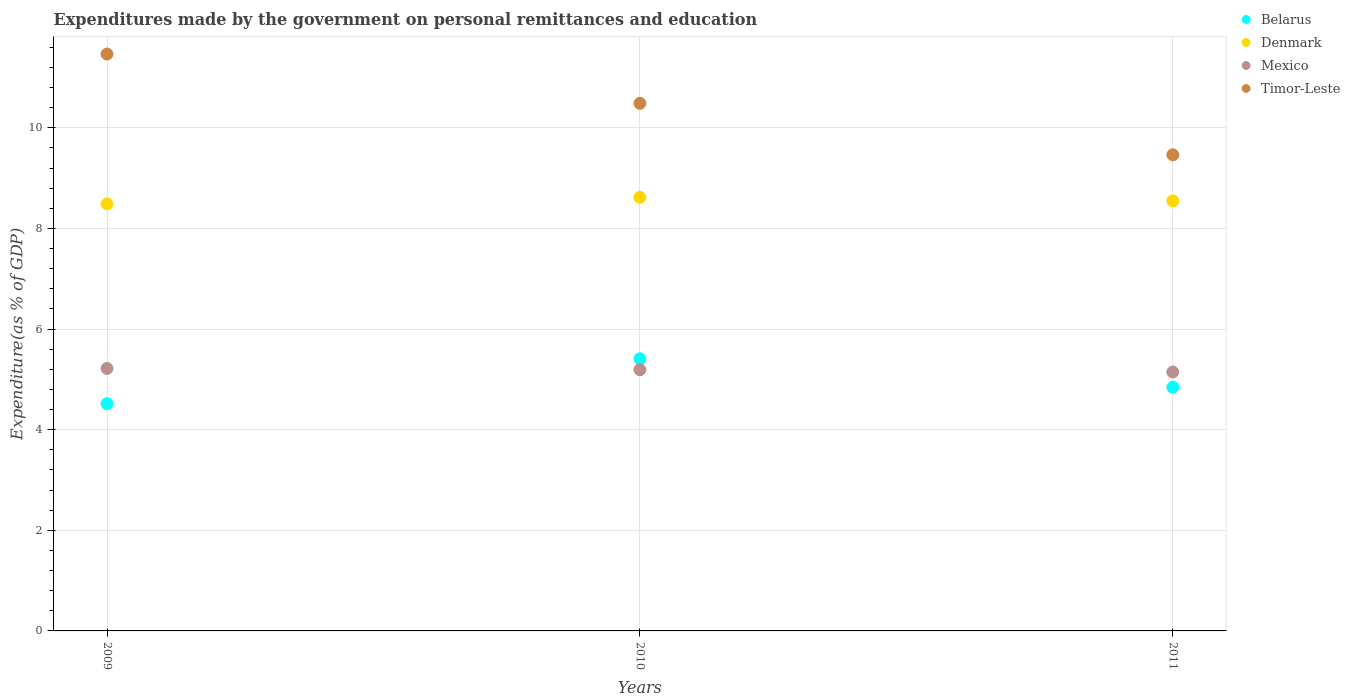What is the expenditures made by the government on personal remittances and education in Timor-Leste in 2010?
Your answer should be very brief. 10.49. Across all years, what is the maximum expenditures made by the government on personal remittances and education in Denmark?
Your answer should be very brief. 8.62. Across all years, what is the minimum expenditures made by the government on personal remittances and education in Timor-Leste?
Ensure brevity in your answer.  9.46. In which year was the expenditures made by the government on personal remittances and education in Timor-Leste minimum?
Give a very brief answer. 2011. What is the total expenditures made by the government on personal remittances and education in Mexico in the graph?
Your response must be concise. 15.56. What is the difference between the expenditures made by the government on personal remittances and education in Belarus in 2009 and that in 2010?
Give a very brief answer. -0.89. What is the difference between the expenditures made by the government on personal remittances and education in Denmark in 2011 and the expenditures made by the government on personal remittances and education in Belarus in 2009?
Your answer should be very brief. 4.03. What is the average expenditures made by the government on personal remittances and education in Belarus per year?
Provide a succinct answer. 4.92. In the year 2010, what is the difference between the expenditures made by the government on personal remittances and education in Mexico and expenditures made by the government on personal remittances and education in Belarus?
Offer a very short reply. -0.22. In how many years, is the expenditures made by the government on personal remittances and education in Denmark greater than 4 %?
Provide a succinct answer. 3. What is the ratio of the expenditures made by the government on personal remittances and education in Mexico in 2010 to that in 2011?
Make the answer very short. 1.01. Is the expenditures made by the government on personal remittances and education in Belarus in 2009 less than that in 2011?
Ensure brevity in your answer.  Yes. What is the difference between the highest and the second highest expenditures made by the government on personal remittances and education in Denmark?
Ensure brevity in your answer.  0.07. What is the difference between the highest and the lowest expenditures made by the government on personal remittances and education in Denmark?
Your answer should be very brief. 0.13. In how many years, is the expenditures made by the government on personal remittances and education in Timor-Leste greater than the average expenditures made by the government on personal remittances and education in Timor-Leste taken over all years?
Your response must be concise. 2. Is it the case that in every year, the sum of the expenditures made by the government on personal remittances and education in Timor-Leste and expenditures made by the government on personal remittances and education in Belarus  is greater than the sum of expenditures made by the government on personal remittances and education in Mexico and expenditures made by the government on personal remittances and education in Denmark?
Make the answer very short. Yes. How many dotlines are there?
Your answer should be very brief. 4. Where does the legend appear in the graph?
Ensure brevity in your answer.  Top right. What is the title of the graph?
Offer a terse response. Expenditures made by the government on personal remittances and education. Does "American Samoa" appear as one of the legend labels in the graph?
Make the answer very short. No. What is the label or title of the Y-axis?
Provide a short and direct response. Expenditure(as % of GDP). What is the Expenditure(as % of GDP) of Belarus in 2009?
Make the answer very short. 4.52. What is the Expenditure(as % of GDP) of Denmark in 2009?
Provide a succinct answer. 8.49. What is the Expenditure(as % of GDP) in Mexico in 2009?
Make the answer very short. 5.22. What is the Expenditure(as % of GDP) of Timor-Leste in 2009?
Your answer should be compact. 11.47. What is the Expenditure(as % of GDP) in Belarus in 2010?
Make the answer very short. 5.41. What is the Expenditure(as % of GDP) of Denmark in 2010?
Your response must be concise. 8.62. What is the Expenditure(as % of GDP) of Mexico in 2010?
Ensure brevity in your answer.  5.19. What is the Expenditure(as % of GDP) of Timor-Leste in 2010?
Offer a very short reply. 10.49. What is the Expenditure(as % of GDP) in Belarus in 2011?
Ensure brevity in your answer.  4.84. What is the Expenditure(as % of GDP) of Denmark in 2011?
Make the answer very short. 8.55. What is the Expenditure(as % of GDP) in Mexico in 2011?
Your answer should be compact. 5.15. What is the Expenditure(as % of GDP) of Timor-Leste in 2011?
Your response must be concise. 9.46. Across all years, what is the maximum Expenditure(as % of GDP) of Belarus?
Your answer should be compact. 5.41. Across all years, what is the maximum Expenditure(as % of GDP) of Denmark?
Your response must be concise. 8.62. Across all years, what is the maximum Expenditure(as % of GDP) of Mexico?
Your answer should be very brief. 5.22. Across all years, what is the maximum Expenditure(as % of GDP) of Timor-Leste?
Ensure brevity in your answer.  11.47. Across all years, what is the minimum Expenditure(as % of GDP) in Belarus?
Ensure brevity in your answer.  4.52. Across all years, what is the minimum Expenditure(as % of GDP) in Denmark?
Provide a short and direct response. 8.49. Across all years, what is the minimum Expenditure(as % of GDP) in Mexico?
Offer a very short reply. 5.15. Across all years, what is the minimum Expenditure(as % of GDP) of Timor-Leste?
Offer a very short reply. 9.46. What is the total Expenditure(as % of GDP) of Belarus in the graph?
Offer a terse response. 14.77. What is the total Expenditure(as % of GDP) in Denmark in the graph?
Offer a very short reply. 25.65. What is the total Expenditure(as % of GDP) of Mexico in the graph?
Keep it short and to the point. 15.56. What is the total Expenditure(as % of GDP) in Timor-Leste in the graph?
Your answer should be very brief. 31.42. What is the difference between the Expenditure(as % of GDP) of Belarus in 2009 and that in 2010?
Offer a very short reply. -0.89. What is the difference between the Expenditure(as % of GDP) of Denmark in 2009 and that in 2010?
Provide a succinct answer. -0.13. What is the difference between the Expenditure(as % of GDP) in Mexico in 2009 and that in 2010?
Your answer should be compact. 0.03. What is the difference between the Expenditure(as % of GDP) of Timor-Leste in 2009 and that in 2010?
Keep it short and to the point. 0.98. What is the difference between the Expenditure(as % of GDP) in Belarus in 2009 and that in 2011?
Make the answer very short. -0.33. What is the difference between the Expenditure(as % of GDP) in Denmark in 2009 and that in 2011?
Ensure brevity in your answer.  -0.06. What is the difference between the Expenditure(as % of GDP) in Mexico in 2009 and that in 2011?
Ensure brevity in your answer.  0.07. What is the difference between the Expenditure(as % of GDP) of Timor-Leste in 2009 and that in 2011?
Make the answer very short. 2. What is the difference between the Expenditure(as % of GDP) of Belarus in 2010 and that in 2011?
Keep it short and to the point. 0.57. What is the difference between the Expenditure(as % of GDP) in Denmark in 2010 and that in 2011?
Offer a terse response. 0.07. What is the difference between the Expenditure(as % of GDP) in Mexico in 2010 and that in 2011?
Make the answer very short. 0.05. What is the difference between the Expenditure(as % of GDP) in Belarus in 2009 and the Expenditure(as % of GDP) in Denmark in 2010?
Provide a succinct answer. -4.1. What is the difference between the Expenditure(as % of GDP) of Belarus in 2009 and the Expenditure(as % of GDP) of Mexico in 2010?
Keep it short and to the point. -0.68. What is the difference between the Expenditure(as % of GDP) in Belarus in 2009 and the Expenditure(as % of GDP) in Timor-Leste in 2010?
Your answer should be very brief. -5.97. What is the difference between the Expenditure(as % of GDP) in Denmark in 2009 and the Expenditure(as % of GDP) in Mexico in 2010?
Provide a succinct answer. 3.3. What is the difference between the Expenditure(as % of GDP) in Denmark in 2009 and the Expenditure(as % of GDP) in Timor-Leste in 2010?
Offer a very short reply. -2. What is the difference between the Expenditure(as % of GDP) of Mexico in 2009 and the Expenditure(as % of GDP) of Timor-Leste in 2010?
Offer a terse response. -5.27. What is the difference between the Expenditure(as % of GDP) in Belarus in 2009 and the Expenditure(as % of GDP) in Denmark in 2011?
Provide a succinct answer. -4.03. What is the difference between the Expenditure(as % of GDP) of Belarus in 2009 and the Expenditure(as % of GDP) of Mexico in 2011?
Make the answer very short. -0.63. What is the difference between the Expenditure(as % of GDP) of Belarus in 2009 and the Expenditure(as % of GDP) of Timor-Leste in 2011?
Offer a terse response. -4.95. What is the difference between the Expenditure(as % of GDP) in Denmark in 2009 and the Expenditure(as % of GDP) in Mexico in 2011?
Your response must be concise. 3.34. What is the difference between the Expenditure(as % of GDP) in Denmark in 2009 and the Expenditure(as % of GDP) in Timor-Leste in 2011?
Give a very brief answer. -0.98. What is the difference between the Expenditure(as % of GDP) in Mexico in 2009 and the Expenditure(as % of GDP) in Timor-Leste in 2011?
Ensure brevity in your answer.  -4.25. What is the difference between the Expenditure(as % of GDP) in Belarus in 2010 and the Expenditure(as % of GDP) in Denmark in 2011?
Provide a short and direct response. -3.14. What is the difference between the Expenditure(as % of GDP) in Belarus in 2010 and the Expenditure(as % of GDP) in Mexico in 2011?
Provide a succinct answer. 0.26. What is the difference between the Expenditure(as % of GDP) in Belarus in 2010 and the Expenditure(as % of GDP) in Timor-Leste in 2011?
Your answer should be compact. -4.05. What is the difference between the Expenditure(as % of GDP) in Denmark in 2010 and the Expenditure(as % of GDP) in Mexico in 2011?
Offer a very short reply. 3.47. What is the difference between the Expenditure(as % of GDP) in Denmark in 2010 and the Expenditure(as % of GDP) in Timor-Leste in 2011?
Make the answer very short. -0.85. What is the difference between the Expenditure(as % of GDP) in Mexico in 2010 and the Expenditure(as % of GDP) in Timor-Leste in 2011?
Offer a terse response. -4.27. What is the average Expenditure(as % of GDP) in Belarus per year?
Give a very brief answer. 4.92. What is the average Expenditure(as % of GDP) in Denmark per year?
Offer a terse response. 8.55. What is the average Expenditure(as % of GDP) of Mexico per year?
Provide a succinct answer. 5.19. What is the average Expenditure(as % of GDP) of Timor-Leste per year?
Provide a short and direct response. 10.47. In the year 2009, what is the difference between the Expenditure(as % of GDP) in Belarus and Expenditure(as % of GDP) in Denmark?
Give a very brief answer. -3.97. In the year 2009, what is the difference between the Expenditure(as % of GDP) in Belarus and Expenditure(as % of GDP) in Mexico?
Your response must be concise. -0.7. In the year 2009, what is the difference between the Expenditure(as % of GDP) in Belarus and Expenditure(as % of GDP) in Timor-Leste?
Your response must be concise. -6.95. In the year 2009, what is the difference between the Expenditure(as % of GDP) of Denmark and Expenditure(as % of GDP) of Mexico?
Your response must be concise. 3.27. In the year 2009, what is the difference between the Expenditure(as % of GDP) in Denmark and Expenditure(as % of GDP) in Timor-Leste?
Your answer should be compact. -2.98. In the year 2009, what is the difference between the Expenditure(as % of GDP) of Mexico and Expenditure(as % of GDP) of Timor-Leste?
Ensure brevity in your answer.  -6.25. In the year 2010, what is the difference between the Expenditure(as % of GDP) of Belarus and Expenditure(as % of GDP) of Denmark?
Offer a very short reply. -3.21. In the year 2010, what is the difference between the Expenditure(as % of GDP) of Belarus and Expenditure(as % of GDP) of Mexico?
Your response must be concise. 0.22. In the year 2010, what is the difference between the Expenditure(as % of GDP) in Belarus and Expenditure(as % of GDP) in Timor-Leste?
Make the answer very short. -5.08. In the year 2010, what is the difference between the Expenditure(as % of GDP) of Denmark and Expenditure(as % of GDP) of Mexico?
Your answer should be compact. 3.43. In the year 2010, what is the difference between the Expenditure(as % of GDP) in Denmark and Expenditure(as % of GDP) in Timor-Leste?
Provide a succinct answer. -1.87. In the year 2010, what is the difference between the Expenditure(as % of GDP) in Mexico and Expenditure(as % of GDP) in Timor-Leste?
Offer a very short reply. -5.3. In the year 2011, what is the difference between the Expenditure(as % of GDP) in Belarus and Expenditure(as % of GDP) in Denmark?
Keep it short and to the point. -3.7. In the year 2011, what is the difference between the Expenditure(as % of GDP) in Belarus and Expenditure(as % of GDP) in Mexico?
Your response must be concise. -0.3. In the year 2011, what is the difference between the Expenditure(as % of GDP) of Belarus and Expenditure(as % of GDP) of Timor-Leste?
Your answer should be compact. -4.62. In the year 2011, what is the difference between the Expenditure(as % of GDP) in Denmark and Expenditure(as % of GDP) in Mexico?
Provide a succinct answer. 3.4. In the year 2011, what is the difference between the Expenditure(as % of GDP) in Denmark and Expenditure(as % of GDP) in Timor-Leste?
Ensure brevity in your answer.  -0.92. In the year 2011, what is the difference between the Expenditure(as % of GDP) in Mexico and Expenditure(as % of GDP) in Timor-Leste?
Your answer should be compact. -4.32. What is the ratio of the Expenditure(as % of GDP) of Belarus in 2009 to that in 2010?
Your response must be concise. 0.83. What is the ratio of the Expenditure(as % of GDP) of Denmark in 2009 to that in 2010?
Your response must be concise. 0.98. What is the ratio of the Expenditure(as % of GDP) of Mexico in 2009 to that in 2010?
Ensure brevity in your answer.  1. What is the ratio of the Expenditure(as % of GDP) in Timor-Leste in 2009 to that in 2010?
Your response must be concise. 1.09. What is the ratio of the Expenditure(as % of GDP) of Belarus in 2009 to that in 2011?
Offer a terse response. 0.93. What is the ratio of the Expenditure(as % of GDP) of Denmark in 2009 to that in 2011?
Your answer should be compact. 0.99. What is the ratio of the Expenditure(as % of GDP) of Mexico in 2009 to that in 2011?
Give a very brief answer. 1.01. What is the ratio of the Expenditure(as % of GDP) in Timor-Leste in 2009 to that in 2011?
Your response must be concise. 1.21. What is the ratio of the Expenditure(as % of GDP) in Belarus in 2010 to that in 2011?
Offer a terse response. 1.12. What is the ratio of the Expenditure(as % of GDP) in Denmark in 2010 to that in 2011?
Give a very brief answer. 1.01. What is the ratio of the Expenditure(as % of GDP) of Mexico in 2010 to that in 2011?
Provide a short and direct response. 1.01. What is the ratio of the Expenditure(as % of GDP) in Timor-Leste in 2010 to that in 2011?
Keep it short and to the point. 1.11. What is the difference between the highest and the second highest Expenditure(as % of GDP) of Belarus?
Your response must be concise. 0.57. What is the difference between the highest and the second highest Expenditure(as % of GDP) in Denmark?
Your answer should be compact. 0.07. What is the difference between the highest and the second highest Expenditure(as % of GDP) of Mexico?
Ensure brevity in your answer.  0.03. What is the difference between the highest and the second highest Expenditure(as % of GDP) in Timor-Leste?
Give a very brief answer. 0.98. What is the difference between the highest and the lowest Expenditure(as % of GDP) of Belarus?
Offer a very short reply. 0.89. What is the difference between the highest and the lowest Expenditure(as % of GDP) of Denmark?
Offer a terse response. 0.13. What is the difference between the highest and the lowest Expenditure(as % of GDP) in Mexico?
Your response must be concise. 0.07. What is the difference between the highest and the lowest Expenditure(as % of GDP) of Timor-Leste?
Offer a very short reply. 2. 